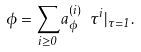<formula> <loc_0><loc_0><loc_500><loc_500>\phi = \sum _ { i \geq 0 } a _ { \phi } ^ { ( i ) } \ \tau ^ { i } | _ { \tau = 1 } .</formula> 